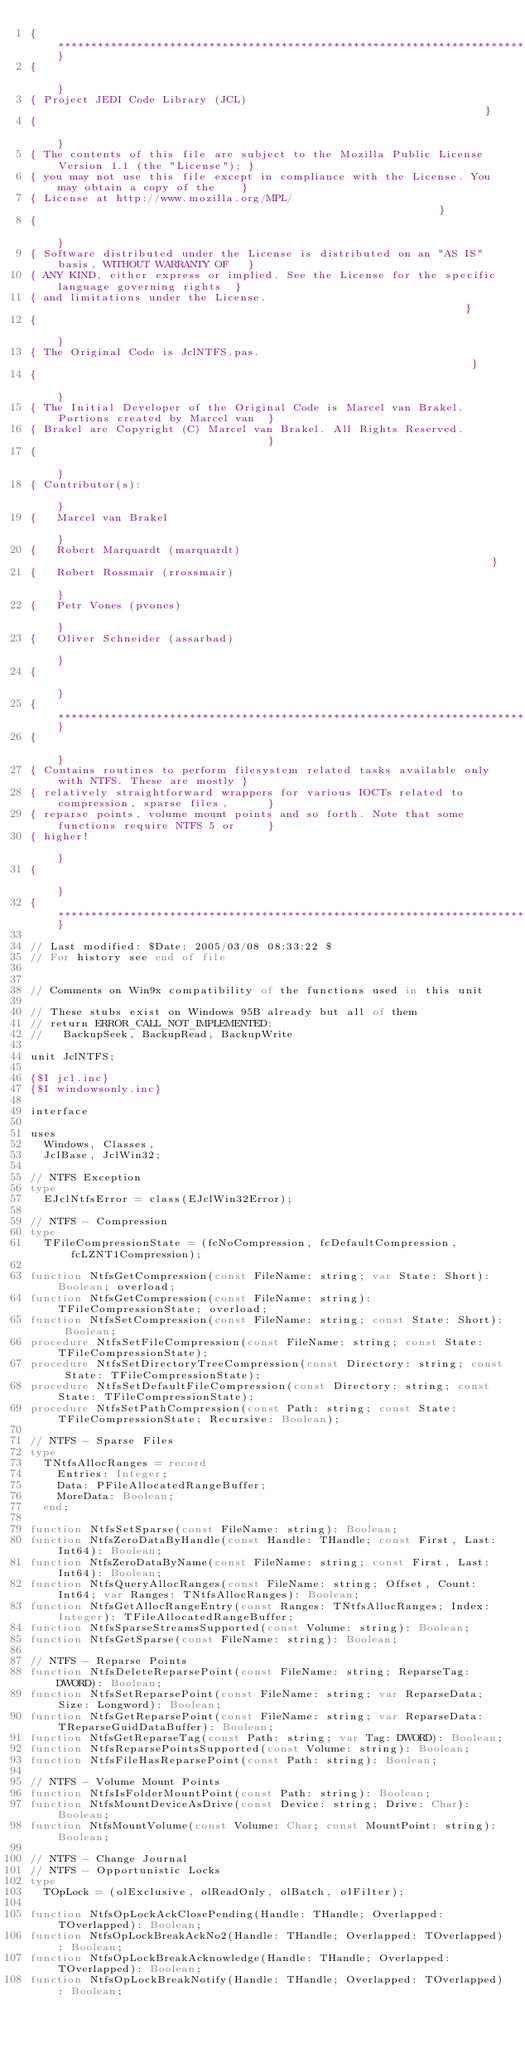<code> <loc_0><loc_0><loc_500><loc_500><_Pascal_>{**************************************************************************************************}
{                                                                                                  }
{ Project JEDI Code Library (JCL)                                                                  }
{                                                                                                  }
{ The contents of this file are subject to the Mozilla Public License Version 1.1 (the "License"); }
{ you may not use this file except in compliance with the License. You may obtain a copy of the    }
{ License at http://www.mozilla.org/MPL/                                                           }
{                                                                                                  }
{ Software distributed under the License is distributed on an "AS IS" basis, WITHOUT WARRANTY OF   }
{ ANY KIND, either express or implied. See the License for the specific language governing rights  }
{ and limitations under the License.                                                               }
{                                                                                                  }
{ The Original Code is JclNTFS.pas.                                                                }
{                                                                                                  }
{ The Initial Developer of the Original Code is Marcel van Brakel. Portions created by Marcel van  }
{ Brakel are Copyright (C) Marcel van Brakel. All Rights Reserved.                                 }
{                                                                                                  }
{ Contributor(s):                                                                                  }
{   Marcel van Brakel                                                                              }
{   Robert Marquardt (marquardt)                                                                   }
{   Robert Rossmair (rrossmair)                                                                    }
{   Petr Vones (pvones)                                                                            }
{   Oliver Schneider (assarbad)                                                                    }
{                                                                                                  }
{**************************************************************************************************}
{                                                                                                  }
{ Contains routines to perform filesystem related tasks available only with NTFS. These are mostly }
{ relatively straightforward wrappers for various IOCTs related to compression, sparse files,      }
{ reparse points, volume mount points and so forth. Note that some functions require NTFS 5 or     }
{ higher!                                                                                          }
{                                                                                                  }
{**************************************************************************************************}

// Last modified: $Date: 2005/03/08 08:33:22 $
// For history see end of file


// Comments on Win9x compatibility of the functions used in this unit

// These stubs exist on Windows 95B already but all of them
// return ERROR_CALL_NOT_IMPLEMENTED:
//   BackupSeek, BackupRead, BackupWrite

unit JclNTFS;

{$I jcl.inc}
{$I windowsonly.inc}

interface

uses
  Windows, Classes,
  JclBase, JclWin32;

// NTFS Exception
type
  EJclNtfsError = class(EJclWin32Error);

// NTFS - Compression
type
  TFileCompressionState = (fcNoCompression, fcDefaultCompression, fcLZNT1Compression);

function NtfsGetCompression(const FileName: string; var State: Short): Boolean; overload;
function NtfsGetCompression(const FileName: string): TFileCompressionState; overload;
function NtfsSetCompression(const FileName: string; const State: Short): Boolean;
procedure NtfsSetFileCompression(const FileName: string; const State: TFileCompressionState);
procedure NtfsSetDirectoryTreeCompression(const Directory: string; const State: TFileCompressionState);
procedure NtfsSetDefaultFileCompression(const Directory: string; const State: TFileCompressionState);
procedure NtfsSetPathCompression(const Path: string; const State: TFileCompressionState; Recursive: Boolean);

// NTFS - Sparse Files
type
  TNtfsAllocRanges = record
    Entries: Integer;
    Data: PFileAllocatedRangeBuffer;
    MoreData: Boolean;
  end;

function NtfsSetSparse(const FileName: string): Boolean;
function NtfsZeroDataByHandle(const Handle: THandle; const First, Last: Int64): Boolean;
function NtfsZeroDataByName(const FileName: string; const First, Last: Int64): Boolean;
function NtfsQueryAllocRanges(const FileName: string; Offset, Count: Int64; var Ranges: TNtfsAllocRanges): Boolean;
function NtfsGetAllocRangeEntry(const Ranges: TNtfsAllocRanges; Index: Integer): TFileAllocatedRangeBuffer;
function NtfsSparseStreamsSupported(const Volume: string): Boolean;
function NtfsGetSparse(const FileName: string): Boolean;

// NTFS - Reparse Points
function NtfsDeleteReparsePoint(const FileName: string; ReparseTag: DWORD): Boolean;
function NtfsSetReparsePoint(const FileName: string; var ReparseData; Size: Longword): Boolean;
function NtfsGetReparsePoint(const FileName: string; var ReparseData: TReparseGuidDataBuffer): Boolean;
function NtfsGetReparseTag(const Path: string; var Tag: DWORD): Boolean;
function NtfsReparsePointsSupported(const Volume: string): Boolean;
function NtfsFileHasReparsePoint(const Path: string): Boolean;

// NTFS - Volume Mount Points
function NtfsIsFolderMountPoint(const Path: string): Boolean;
function NtfsMountDeviceAsDrive(const Device: string; Drive: Char): Boolean;
function NtfsMountVolume(const Volume: Char; const MountPoint: string): Boolean;

// NTFS - Change Journal
// NTFS - Opportunistic Locks
type
  TOpLock = (olExclusive, olReadOnly, olBatch, olFilter);

function NtfsOpLockAckClosePending(Handle: THandle; Overlapped: TOverlapped): Boolean;
function NtfsOpLockBreakAckNo2(Handle: THandle; Overlapped: TOverlapped): Boolean;
function NtfsOpLockBreakAcknowledge(Handle: THandle; Overlapped: TOverlapped): Boolean;
function NtfsOpLockBreakNotify(Handle: THandle; Overlapped: TOverlapped): Boolean;</code> 